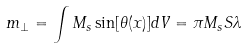<formula> <loc_0><loc_0><loc_500><loc_500>m _ { \perp } = \int M _ { s } \sin [ \theta ( x ) ] d V = \pi M _ { s } S \lambda</formula> 